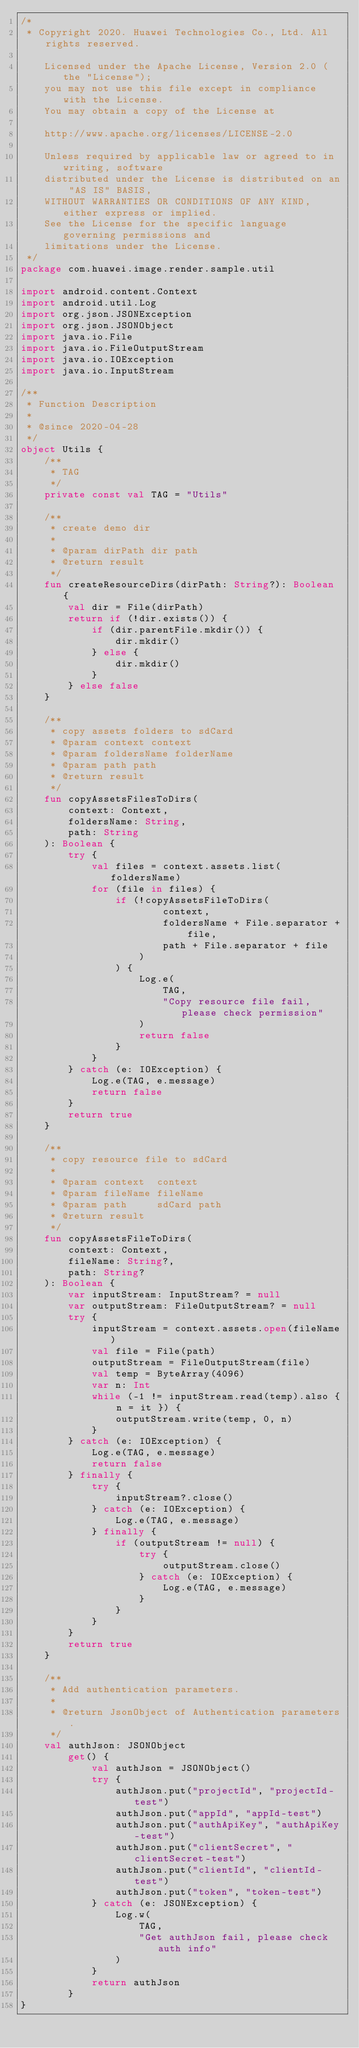<code> <loc_0><loc_0><loc_500><loc_500><_Kotlin_>/*
 * Copyright 2020. Huawei Technologies Co., Ltd. All rights reserved.

    Licensed under the Apache License, Version 2.0 (the "License");
    you may not use this file except in compliance with the License.
    You may obtain a copy of the License at

    http://www.apache.org/licenses/LICENSE-2.0

    Unless required by applicable law or agreed to in writing, software
    distributed under the License is distributed on an "AS IS" BASIS,
    WITHOUT WARRANTIES OR CONDITIONS OF ANY KIND, either express or implied.
    See the License for the specific language governing permissions and
    limitations under the License.
 */
package com.huawei.image.render.sample.util

import android.content.Context
import android.util.Log
import org.json.JSONException
import org.json.JSONObject
import java.io.File
import java.io.FileOutputStream
import java.io.IOException
import java.io.InputStream

/**
 * Function Description
 *
 * @since 2020-04-28
 */
object Utils {
    /**
     * TAG
     */
    private const val TAG = "Utils"

    /**
     * create demo dir
     *
     * @param dirPath dir path
     * @return result
     */
    fun createResourceDirs(dirPath: String?): Boolean {
        val dir = File(dirPath)
        return if (!dir.exists()) {
            if (dir.parentFile.mkdir()) {
                dir.mkdir()
            } else {
                dir.mkdir()
            }
        } else false
    }

    /**
     * copy assets folders to sdCard
     * @param context context
     * @param foldersName folderName
     * @param path path
     * @return result
     */
    fun copyAssetsFilesToDirs(
        context: Context,
        foldersName: String,
        path: String
    ): Boolean {
        try {
            val files = context.assets.list(foldersName)
            for (file in files) {
                if (!copyAssetsFileToDirs(
                        context,
                        foldersName + File.separator + file,
                        path + File.separator + file
                    )
                ) {
                    Log.e(
                        TAG,
                        "Copy resource file fail, please check permission"
                    )
                    return false
                }
            }
        } catch (e: IOException) {
            Log.e(TAG, e.message)
            return false
        }
        return true
    }

    /**
     * copy resource file to sdCard
     *
     * @param context  context
     * @param fileName fileName
     * @param path     sdCard path
     * @return result
     */
    fun copyAssetsFileToDirs(
        context: Context,
        fileName: String?,
        path: String?
    ): Boolean {
        var inputStream: InputStream? = null
        var outputStream: FileOutputStream? = null
        try {
            inputStream = context.assets.open(fileName)
            val file = File(path)
            outputStream = FileOutputStream(file)
            val temp = ByteArray(4096)
            var n: Int
            while (-1 != inputStream.read(temp).also { n = it }) {
                outputStream.write(temp, 0, n)
            }
        } catch (e: IOException) {
            Log.e(TAG, e.message)
            return false
        } finally {
            try {
                inputStream?.close()
            } catch (e: IOException) {
                Log.e(TAG, e.message)
            } finally {
                if (outputStream != null) {
                    try {
                        outputStream.close()
                    } catch (e: IOException) {
                        Log.e(TAG, e.message)
                    }
                }
            }
        }
        return true
    }

    /**
     * Add authentication parameters.
     *
     * @return JsonObject of Authentication parameters.
     */
    val authJson: JSONObject
        get() {
            val authJson = JSONObject()
            try {
                authJson.put("projectId", "projectId-test")
                authJson.put("appId", "appId-test")
                authJson.put("authApiKey", "authApiKey-test")
                authJson.put("clientSecret", "clientSecret-test")
                authJson.put("clientId", "clientId-test")
                authJson.put("token", "token-test")
            } catch (e: JSONException) {
                Log.w(
                    TAG,
                    "Get authJson fail, please check auth info"
                )
            }
            return authJson
        }
}</code> 